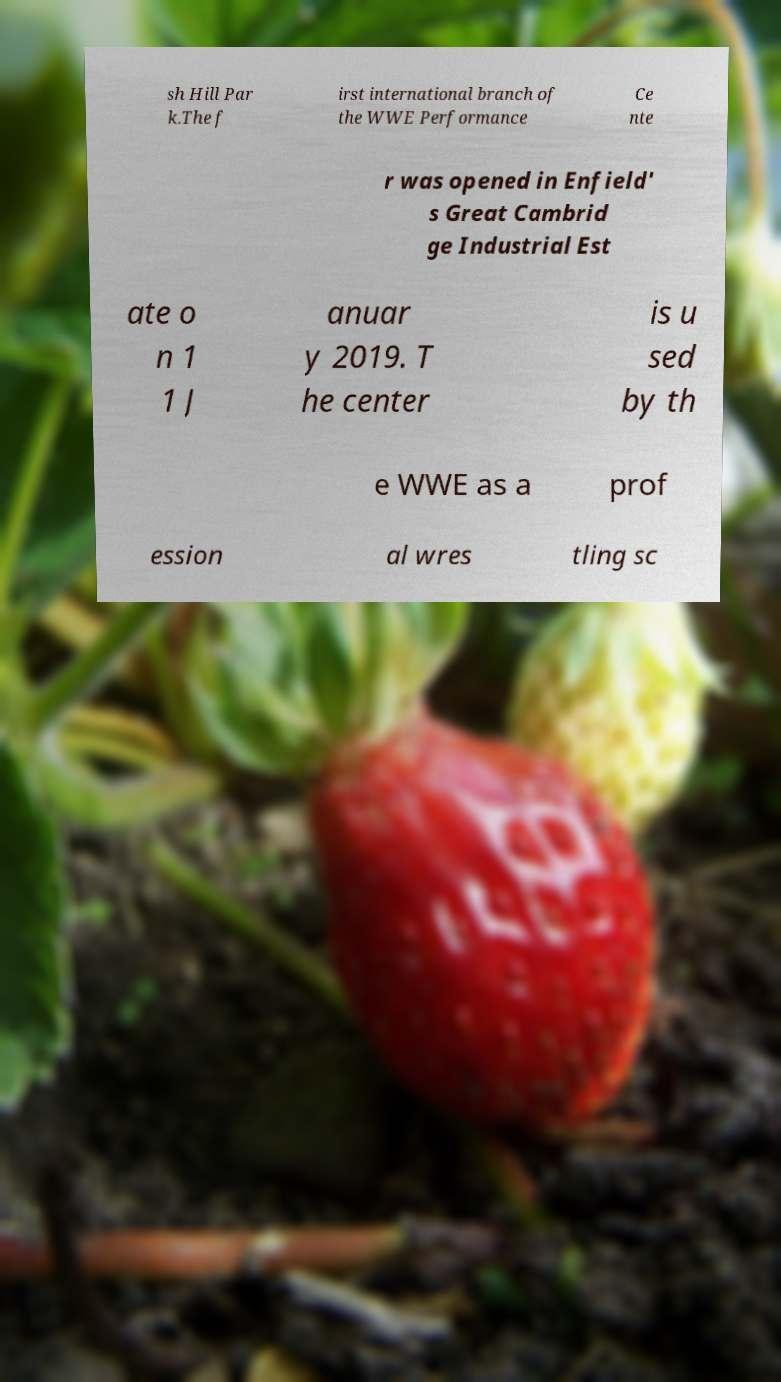What messages or text are displayed in this image? I need them in a readable, typed format. sh Hill Par k.The f irst international branch of the WWE Performance Ce nte r was opened in Enfield' s Great Cambrid ge Industrial Est ate o n 1 1 J anuar y 2019. T he center is u sed by th e WWE as a prof ession al wres tling sc 